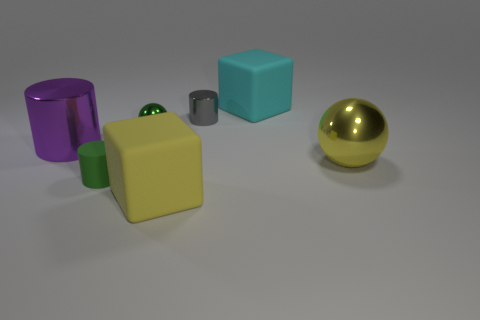Does the small metallic sphere have the same color as the small matte cylinder?
Offer a very short reply. Yes. There is a small thing that is the same color as the rubber cylinder; what is its material?
Make the answer very short. Metal. What is the large thing that is both right of the large purple cylinder and on the left side of the big cyan block made of?
Your response must be concise. Rubber. What is the material of the large purple object that is the same shape as the gray thing?
Offer a terse response. Metal. What number of objects are either matte things in front of the cyan thing or metallic objects to the left of the gray thing?
Provide a short and direct response. 4. There is a small green metal thing; is it the same shape as the tiny gray metal object that is in front of the big cyan rubber thing?
Your response must be concise. No. What shape is the big rubber thing that is behind the small object that is to the left of the shiny sphere on the left side of the large cyan rubber thing?
Provide a succinct answer. Cube. What is the shape of the large metal object that is right of the large rubber block in front of the tiny green rubber cylinder?
Provide a succinct answer. Sphere. Do the large metallic object right of the green cylinder and the large purple metal thing have the same shape?
Your answer should be very brief. No. What is the color of the tiny object that is in front of the large purple metallic cylinder?
Keep it short and to the point. Green. 